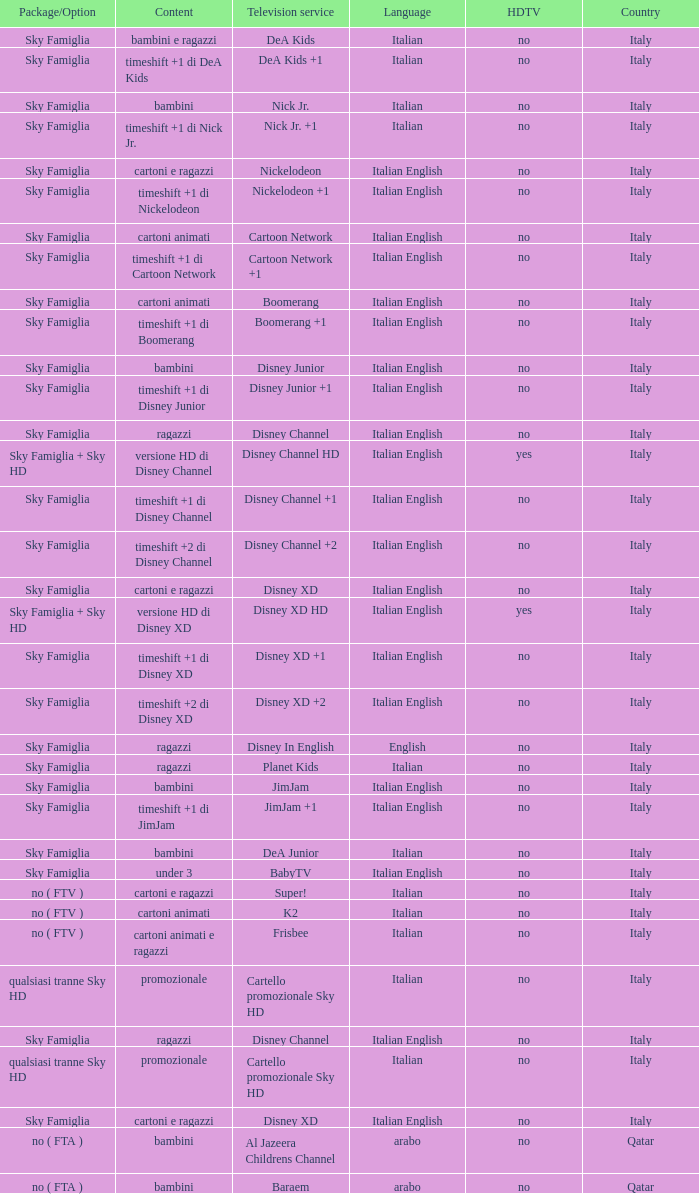What is the HDTV when the Package/Option is sky famiglia, and a Television service of boomerang +1? No. 